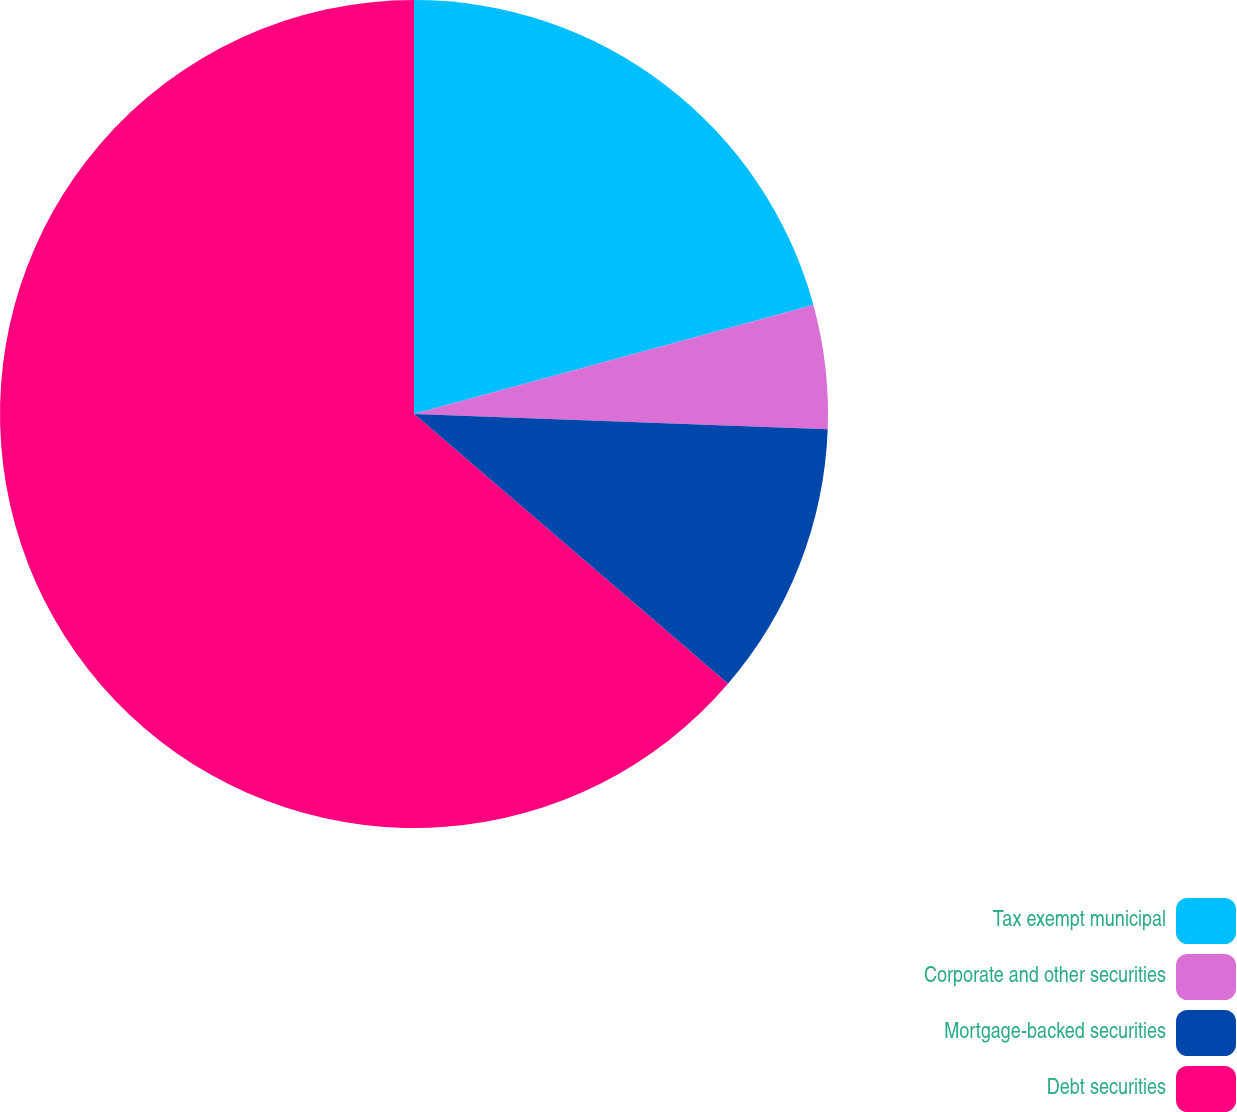Convert chart. <chart><loc_0><loc_0><loc_500><loc_500><pie_chart><fcel>Tax exempt municipal<fcel>Corporate and other securities<fcel>Mortgage-backed securities<fcel>Debt securities<nl><fcel>20.76%<fcel>4.83%<fcel>10.71%<fcel>63.7%<nl></chart> 